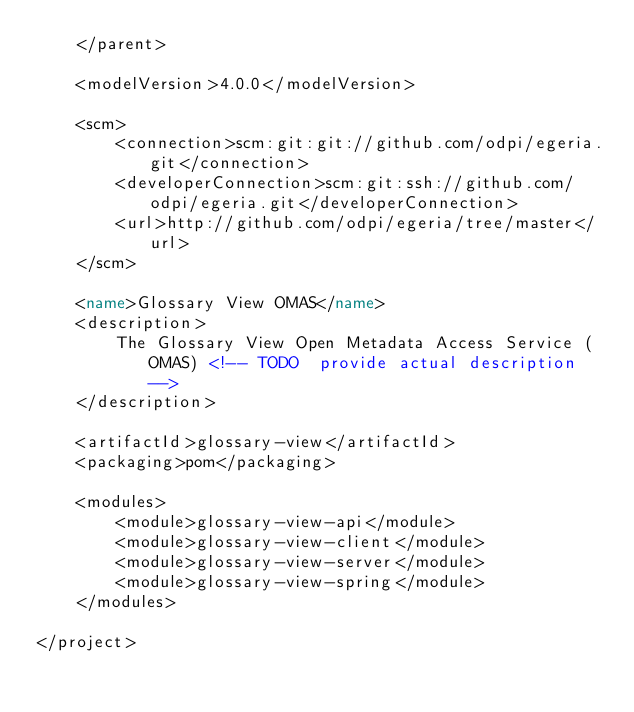Convert code to text. <code><loc_0><loc_0><loc_500><loc_500><_XML_>    </parent>

    <modelVersion>4.0.0</modelVersion>

    <scm>
        <connection>scm:git:git://github.com/odpi/egeria.git</connection>
        <developerConnection>scm:git:ssh://github.com/odpi/egeria.git</developerConnection>
        <url>http://github.com/odpi/egeria/tree/master</url>
    </scm>

    <name>Glossary View OMAS</name>
    <description>
        The Glossary View Open Metadata Access Service (OMAS) <!-- TODO  provide actual description -->
    </description>

    <artifactId>glossary-view</artifactId>
    <packaging>pom</packaging>

    <modules>
        <module>glossary-view-api</module>
        <module>glossary-view-client</module>
        <module>glossary-view-server</module>
        <module>glossary-view-spring</module>
    </modules>

</project>
</code> 